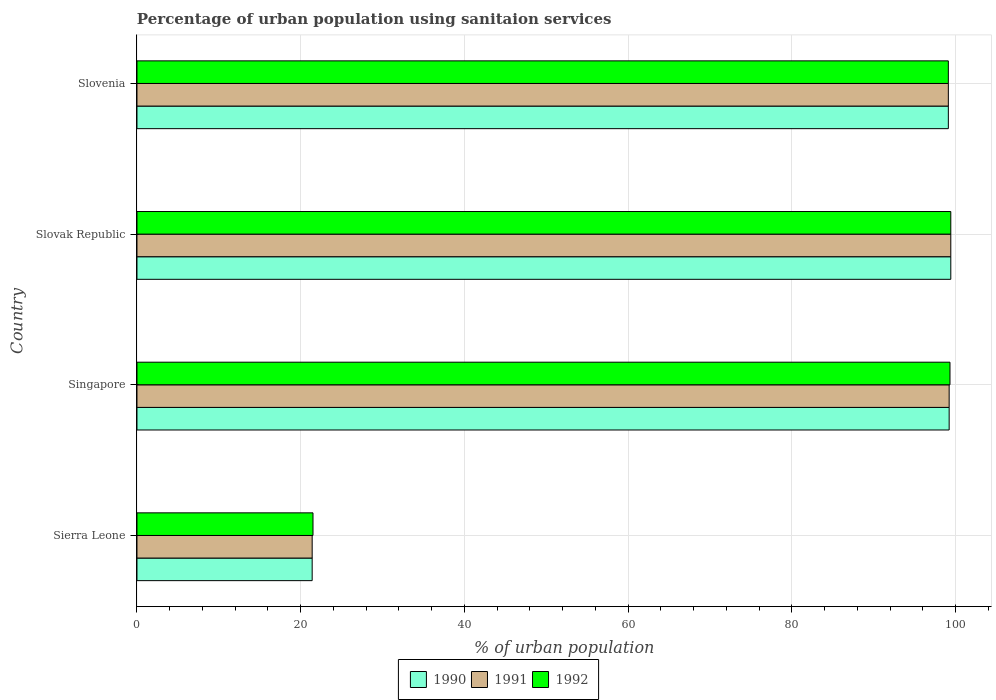How many different coloured bars are there?
Your answer should be compact. 3. How many groups of bars are there?
Ensure brevity in your answer.  4. Are the number of bars per tick equal to the number of legend labels?
Ensure brevity in your answer.  Yes. How many bars are there on the 2nd tick from the bottom?
Offer a terse response. 3. What is the label of the 1st group of bars from the top?
Keep it short and to the point. Slovenia. In how many cases, is the number of bars for a given country not equal to the number of legend labels?
Your answer should be compact. 0. What is the percentage of urban population using sanitaion services in 1990 in Sierra Leone?
Provide a succinct answer. 21.4. Across all countries, what is the maximum percentage of urban population using sanitaion services in 1992?
Your answer should be very brief. 99.4. Across all countries, what is the minimum percentage of urban population using sanitaion services in 1991?
Provide a short and direct response. 21.4. In which country was the percentage of urban population using sanitaion services in 1991 maximum?
Your response must be concise. Slovak Republic. In which country was the percentage of urban population using sanitaion services in 1991 minimum?
Ensure brevity in your answer.  Sierra Leone. What is the total percentage of urban population using sanitaion services in 1990 in the graph?
Give a very brief answer. 319.1. What is the difference between the percentage of urban population using sanitaion services in 1992 in Slovak Republic and that in Slovenia?
Provide a succinct answer. 0.3. What is the difference between the percentage of urban population using sanitaion services in 1990 in Sierra Leone and the percentage of urban population using sanitaion services in 1992 in Slovenia?
Make the answer very short. -77.7. What is the average percentage of urban population using sanitaion services in 1992 per country?
Provide a succinct answer. 79.82. What is the difference between the percentage of urban population using sanitaion services in 1990 and percentage of urban population using sanitaion services in 1992 in Singapore?
Make the answer very short. -0.1. What is the ratio of the percentage of urban population using sanitaion services in 1990 in Sierra Leone to that in Slovak Republic?
Provide a short and direct response. 0.22. Is the difference between the percentage of urban population using sanitaion services in 1990 in Singapore and Slovenia greater than the difference between the percentage of urban population using sanitaion services in 1992 in Singapore and Slovenia?
Provide a short and direct response. No. What is the difference between the highest and the second highest percentage of urban population using sanitaion services in 1992?
Your answer should be very brief. 0.1. What is the difference between the highest and the lowest percentage of urban population using sanitaion services in 1990?
Make the answer very short. 78. In how many countries, is the percentage of urban population using sanitaion services in 1990 greater than the average percentage of urban population using sanitaion services in 1990 taken over all countries?
Keep it short and to the point. 3. Is the sum of the percentage of urban population using sanitaion services in 1992 in Singapore and Slovak Republic greater than the maximum percentage of urban population using sanitaion services in 1991 across all countries?
Your answer should be very brief. Yes. How many bars are there?
Make the answer very short. 12. Are all the bars in the graph horizontal?
Provide a succinct answer. Yes. How many countries are there in the graph?
Give a very brief answer. 4. What is the difference between two consecutive major ticks on the X-axis?
Offer a very short reply. 20. Does the graph contain any zero values?
Your response must be concise. No. What is the title of the graph?
Give a very brief answer. Percentage of urban population using sanitaion services. What is the label or title of the X-axis?
Give a very brief answer. % of urban population. What is the label or title of the Y-axis?
Ensure brevity in your answer.  Country. What is the % of urban population in 1990 in Sierra Leone?
Offer a very short reply. 21.4. What is the % of urban population of 1991 in Sierra Leone?
Provide a succinct answer. 21.4. What is the % of urban population in 1992 in Sierra Leone?
Provide a succinct answer. 21.5. What is the % of urban population of 1990 in Singapore?
Give a very brief answer. 99.2. What is the % of urban population in 1991 in Singapore?
Keep it short and to the point. 99.2. What is the % of urban population in 1992 in Singapore?
Your answer should be compact. 99.3. What is the % of urban population of 1990 in Slovak Republic?
Give a very brief answer. 99.4. What is the % of urban population in 1991 in Slovak Republic?
Provide a short and direct response. 99.4. What is the % of urban population of 1992 in Slovak Republic?
Your answer should be very brief. 99.4. What is the % of urban population of 1990 in Slovenia?
Your response must be concise. 99.1. What is the % of urban population in 1991 in Slovenia?
Provide a succinct answer. 99.1. What is the % of urban population of 1992 in Slovenia?
Keep it short and to the point. 99.1. Across all countries, what is the maximum % of urban population of 1990?
Make the answer very short. 99.4. Across all countries, what is the maximum % of urban population of 1991?
Make the answer very short. 99.4. Across all countries, what is the maximum % of urban population in 1992?
Ensure brevity in your answer.  99.4. Across all countries, what is the minimum % of urban population in 1990?
Make the answer very short. 21.4. Across all countries, what is the minimum % of urban population in 1991?
Your answer should be very brief. 21.4. Across all countries, what is the minimum % of urban population in 1992?
Keep it short and to the point. 21.5. What is the total % of urban population of 1990 in the graph?
Ensure brevity in your answer.  319.1. What is the total % of urban population of 1991 in the graph?
Ensure brevity in your answer.  319.1. What is the total % of urban population of 1992 in the graph?
Give a very brief answer. 319.3. What is the difference between the % of urban population of 1990 in Sierra Leone and that in Singapore?
Make the answer very short. -77.8. What is the difference between the % of urban population of 1991 in Sierra Leone and that in Singapore?
Provide a short and direct response. -77.8. What is the difference between the % of urban population of 1992 in Sierra Leone and that in Singapore?
Give a very brief answer. -77.8. What is the difference between the % of urban population in 1990 in Sierra Leone and that in Slovak Republic?
Offer a terse response. -78. What is the difference between the % of urban population of 1991 in Sierra Leone and that in Slovak Republic?
Ensure brevity in your answer.  -78. What is the difference between the % of urban population in 1992 in Sierra Leone and that in Slovak Republic?
Your answer should be compact. -77.9. What is the difference between the % of urban population of 1990 in Sierra Leone and that in Slovenia?
Your answer should be very brief. -77.7. What is the difference between the % of urban population of 1991 in Sierra Leone and that in Slovenia?
Offer a terse response. -77.7. What is the difference between the % of urban population of 1992 in Sierra Leone and that in Slovenia?
Your answer should be very brief. -77.6. What is the difference between the % of urban population in 1990 in Singapore and that in Slovak Republic?
Your answer should be very brief. -0.2. What is the difference between the % of urban population in 1990 in Singapore and that in Slovenia?
Provide a succinct answer. 0.1. What is the difference between the % of urban population in 1990 in Slovak Republic and that in Slovenia?
Your answer should be compact. 0.3. What is the difference between the % of urban population of 1991 in Slovak Republic and that in Slovenia?
Give a very brief answer. 0.3. What is the difference between the % of urban population of 1992 in Slovak Republic and that in Slovenia?
Keep it short and to the point. 0.3. What is the difference between the % of urban population in 1990 in Sierra Leone and the % of urban population in 1991 in Singapore?
Make the answer very short. -77.8. What is the difference between the % of urban population in 1990 in Sierra Leone and the % of urban population in 1992 in Singapore?
Make the answer very short. -77.9. What is the difference between the % of urban population in 1991 in Sierra Leone and the % of urban population in 1992 in Singapore?
Make the answer very short. -77.9. What is the difference between the % of urban population in 1990 in Sierra Leone and the % of urban population in 1991 in Slovak Republic?
Keep it short and to the point. -78. What is the difference between the % of urban population in 1990 in Sierra Leone and the % of urban population in 1992 in Slovak Republic?
Ensure brevity in your answer.  -78. What is the difference between the % of urban population of 1991 in Sierra Leone and the % of urban population of 1992 in Slovak Republic?
Your response must be concise. -78. What is the difference between the % of urban population in 1990 in Sierra Leone and the % of urban population in 1991 in Slovenia?
Your response must be concise. -77.7. What is the difference between the % of urban population in 1990 in Sierra Leone and the % of urban population in 1992 in Slovenia?
Offer a very short reply. -77.7. What is the difference between the % of urban population of 1991 in Sierra Leone and the % of urban population of 1992 in Slovenia?
Give a very brief answer. -77.7. What is the difference between the % of urban population in 1990 in Singapore and the % of urban population in 1991 in Slovak Republic?
Your answer should be very brief. -0.2. What is the difference between the % of urban population in 1990 in Singapore and the % of urban population in 1992 in Slovak Republic?
Your response must be concise. -0.2. What is the difference between the % of urban population in 1990 in Slovak Republic and the % of urban population in 1991 in Slovenia?
Provide a succinct answer. 0.3. What is the difference between the % of urban population in 1990 in Slovak Republic and the % of urban population in 1992 in Slovenia?
Your answer should be very brief. 0.3. What is the average % of urban population of 1990 per country?
Provide a succinct answer. 79.78. What is the average % of urban population of 1991 per country?
Keep it short and to the point. 79.78. What is the average % of urban population in 1992 per country?
Give a very brief answer. 79.83. What is the difference between the % of urban population in 1990 and % of urban population in 1991 in Sierra Leone?
Provide a succinct answer. 0. What is the difference between the % of urban population in 1990 and % of urban population in 1991 in Singapore?
Keep it short and to the point. 0. What is the difference between the % of urban population of 1991 and % of urban population of 1992 in Slovak Republic?
Provide a succinct answer. 0. What is the difference between the % of urban population of 1990 and % of urban population of 1991 in Slovenia?
Your response must be concise. 0. What is the ratio of the % of urban population of 1990 in Sierra Leone to that in Singapore?
Provide a short and direct response. 0.22. What is the ratio of the % of urban population in 1991 in Sierra Leone to that in Singapore?
Make the answer very short. 0.22. What is the ratio of the % of urban population in 1992 in Sierra Leone to that in Singapore?
Your answer should be very brief. 0.22. What is the ratio of the % of urban population of 1990 in Sierra Leone to that in Slovak Republic?
Keep it short and to the point. 0.22. What is the ratio of the % of urban population of 1991 in Sierra Leone to that in Slovak Republic?
Provide a short and direct response. 0.22. What is the ratio of the % of urban population in 1992 in Sierra Leone to that in Slovak Republic?
Keep it short and to the point. 0.22. What is the ratio of the % of urban population in 1990 in Sierra Leone to that in Slovenia?
Give a very brief answer. 0.22. What is the ratio of the % of urban population in 1991 in Sierra Leone to that in Slovenia?
Give a very brief answer. 0.22. What is the ratio of the % of urban population in 1992 in Sierra Leone to that in Slovenia?
Make the answer very short. 0.22. What is the ratio of the % of urban population of 1991 in Singapore to that in Slovak Republic?
Your answer should be compact. 1. What is the ratio of the % of urban population of 1991 in Singapore to that in Slovenia?
Keep it short and to the point. 1. What is the ratio of the % of urban population in 1991 in Slovak Republic to that in Slovenia?
Keep it short and to the point. 1. What is the difference between the highest and the second highest % of urban population of 1990?
Your response must be concise. 0.2. What is the difference between the highest and the second highest % of urban population in 1991?
Your response must be concise. 0.2. What is the difference between the highest and the second highest % of urban population in 1992?
Your response must be concise. 0.1. What is the difference between the highest and the lowest % of urban population in 1991?
Keep it short and to the point. 78. What is the difference between the highest and the lowest % of urban population of 1992?
Offer a very short reply. 77.9. 